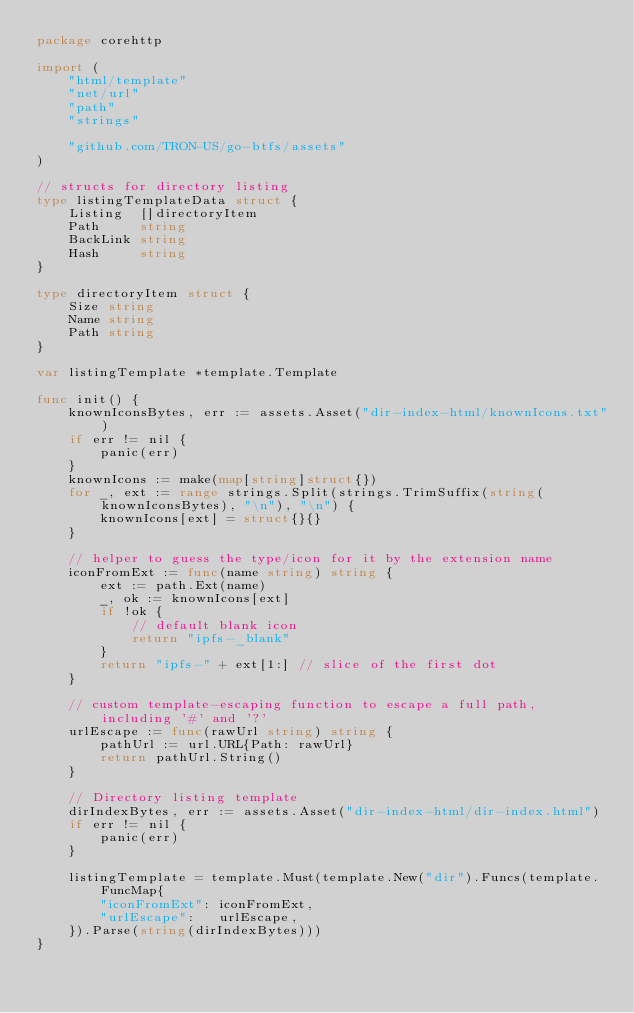<code> <loc_0><loc_0><loc_500><loc_500><_Go_>package corehttp

import (
	"html/template"
	"net/url"
	"path"
	"strings"

	"github.com/TRON-US/go-btfs/assets"
)

// structs for directory listing
type listingTemplateData struct {
	Listing  []directoryItem
	Path     string
	BackLink string
	Hash     string
}

type directoryItem struct {
	Size string
	Name string
	Path string
}

var listingTemplate *template.Template

func init() {
	knownIconsBytes, err := assets.Asset("dir-index-html/knownIcons.txt")
	if err != nil {
		panic(err)
	}
	knownIcons := make(map[string]struct{})
	for _, ext := range strings.Split(strings.TrimSuffix(string(knownIconsBytes), "\n"), "\n") {
		knownIcons[ext] = struct{}{}
	}

	// helper to guess the type/icon for it by the extension name
	iconFromExt := func(name string) string {
		ext := path.Ext(name)
		_, ok := knownIcons[ext]
		if !ok {
			// default blank icon
			return "ipfs-_blank"
		}
		return "ipfs-" + ext[1:] // slice of the first dot
	}

	// custom template-escaping function to escape a full path, including '#' and '?'
	urlEscape := func(rawUrl string) string {
		pathUrl := url.URL{Path: rawUrl}
		return pathUrl.String()
	}

	// Directory listing template
	dirIndexBytes, err := assets.Asset("dir-index-html/dir-index.html")
	if err != nil {
		panic(err)
	}

	listingTemplate = template.Must(template.New("dir").Funcs(template.FuncMap{
		"iconFromExt": iconFromExt,
		"urlEscape":   urlEscape,
	}).Parse(string(dirIndexBytes)))
}
</code> 